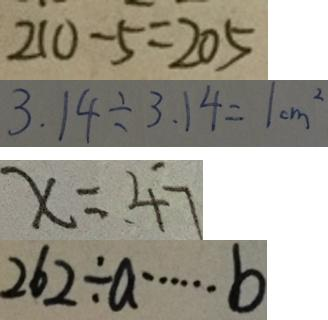Convert formula to latex. <formula><loc_0><loc_0><loc_500><loc_500>2 1 0 - 5 = 2 0 5 
 3 . 1 4 \div 3 . 1 4 = 1 c m ^ { 2 } 
 x = 4 7 
 2 6 2 \div a \cdots b</formula> 